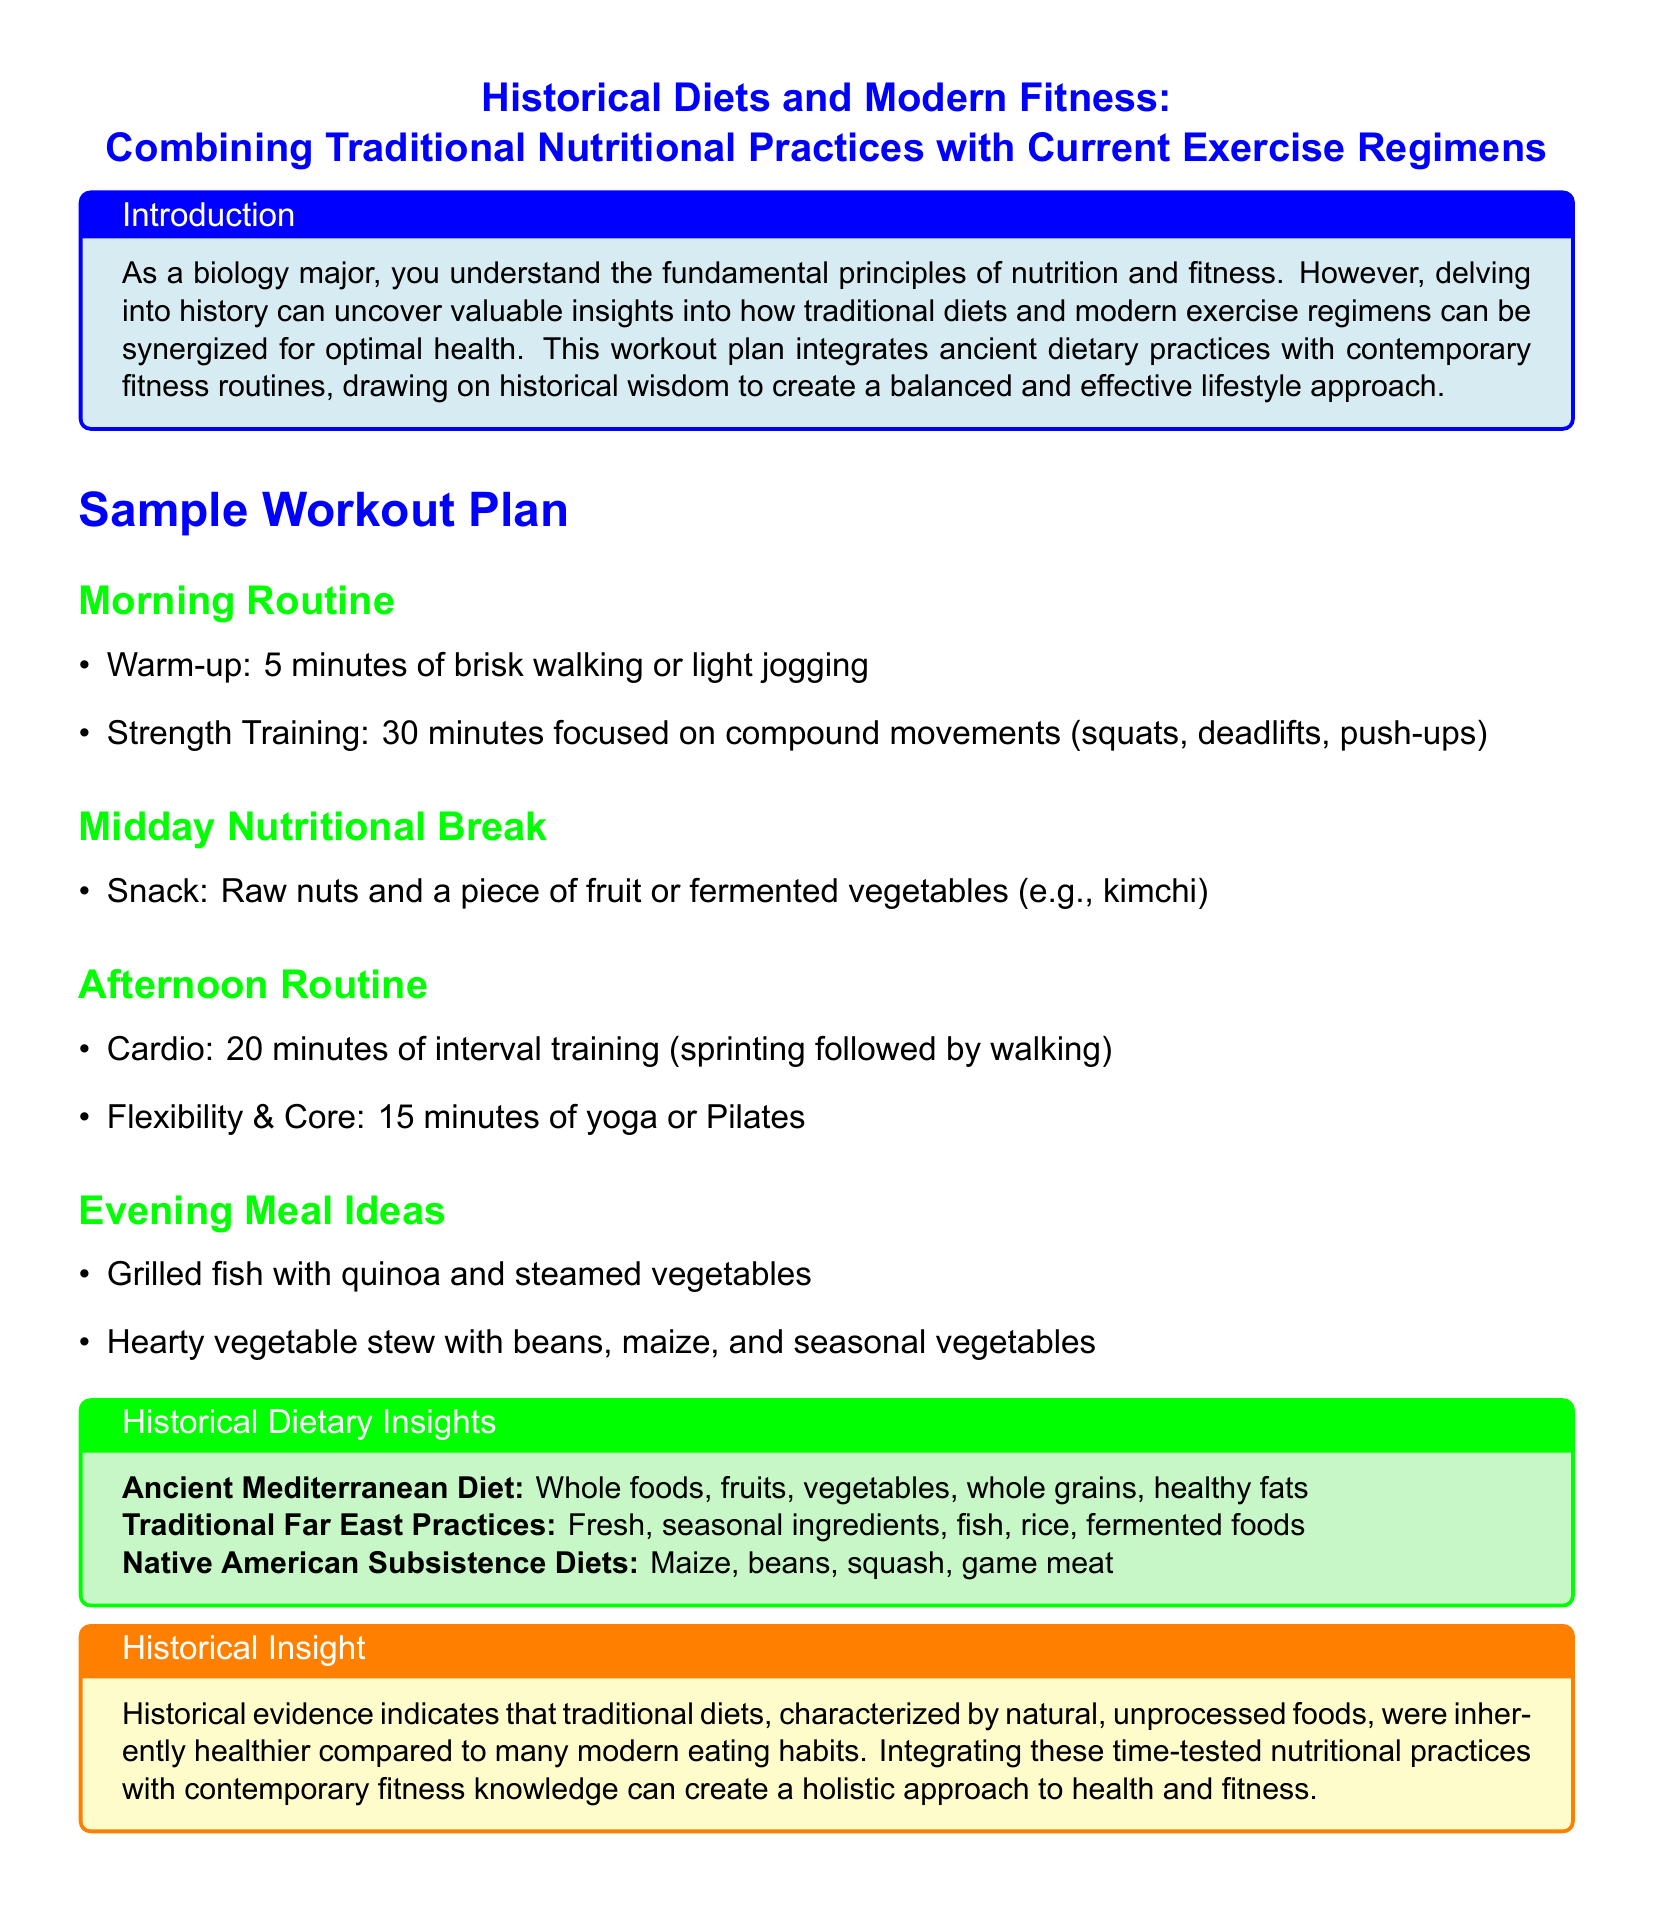What are the two types of exercises included in the morning routine? The morning routine includes strength training and warm-up exercises.
Answer: warm-up, strength training How long is the cardio session in the afternoon routine? The afternoon routine specifies that the cardio session lasts for 20 minutes.
Answer: 20 minutes What type of snack is suggested for the midday nutritional break? The document recommends raw nuts and a piece of fruit or fermented vegetables for a snack.
Answer: raw nuts and fruit or fermented vegetables Which diets are highlighted in the historical dietary insights? The historical dietary insights mention the Ancient Mediterranean diet, Traditional Far East practices, and Native American subsistence diets.
Answer: Ancient Mediterranean, Traditional Far East, Native American What type of food characterizes historical diets according to the document? The document states that historical diets consisted of natural, unprocessed foods, making them inherently healthier.
Answer: natural, unprocessed foods What is the main focus of the strength training session? The strength training session focuses on compound movements according to the morning routine.
Answer: compound movements What are the evening meal ideas that incorporate historical dietary practices? The document lists grilled fish with quinoa and vegetables, and vegetable stew with beans, maize, and seasonal vegetables as meal ideas.
Answer: grilled fish with quinoa, hearty vegetable stew What insight does the document provide regarding traditional diets? The document indicates that traditional diets were healthier compared to many modern eating habits.
Answer: healthier compared to modern diets What is the primary purpose of the workout plan described in the document? The workout plan aims to integrate traditional dietary practices with contemporary fitness regimens for optimal health.
Answer: integrate traditional diets with modern fitness 